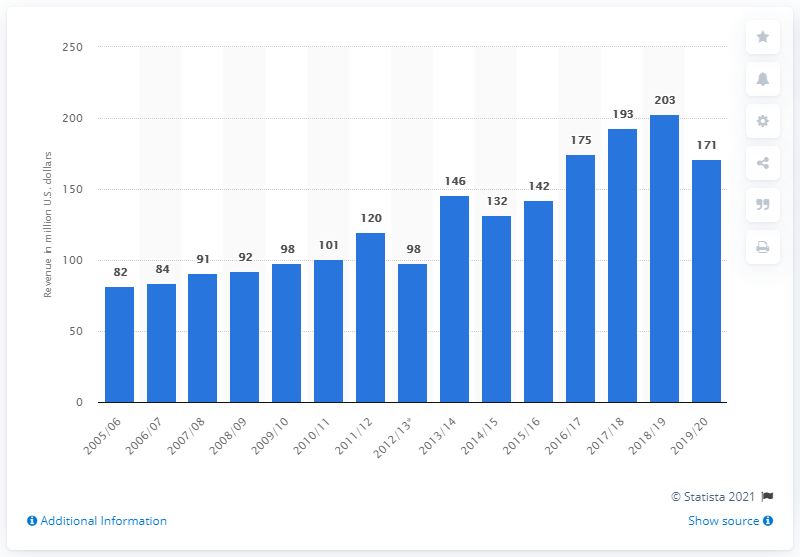List a handful of essential elements in this visual. The Los Angeles Kings earned a significant amount of money in the 2019/20 season, which amounted to 171 million dollars. 